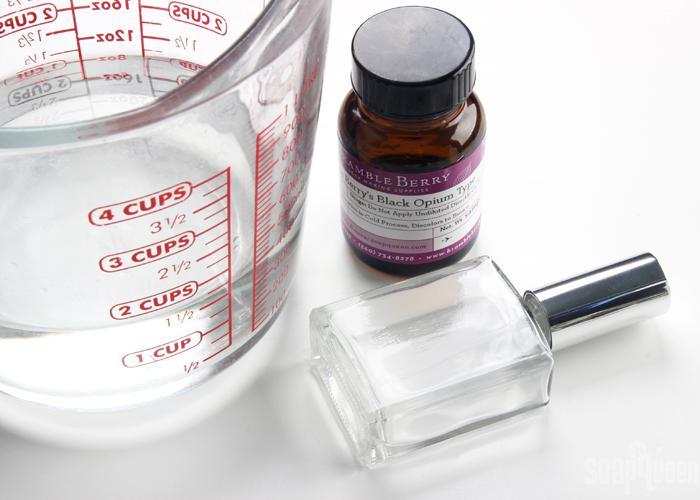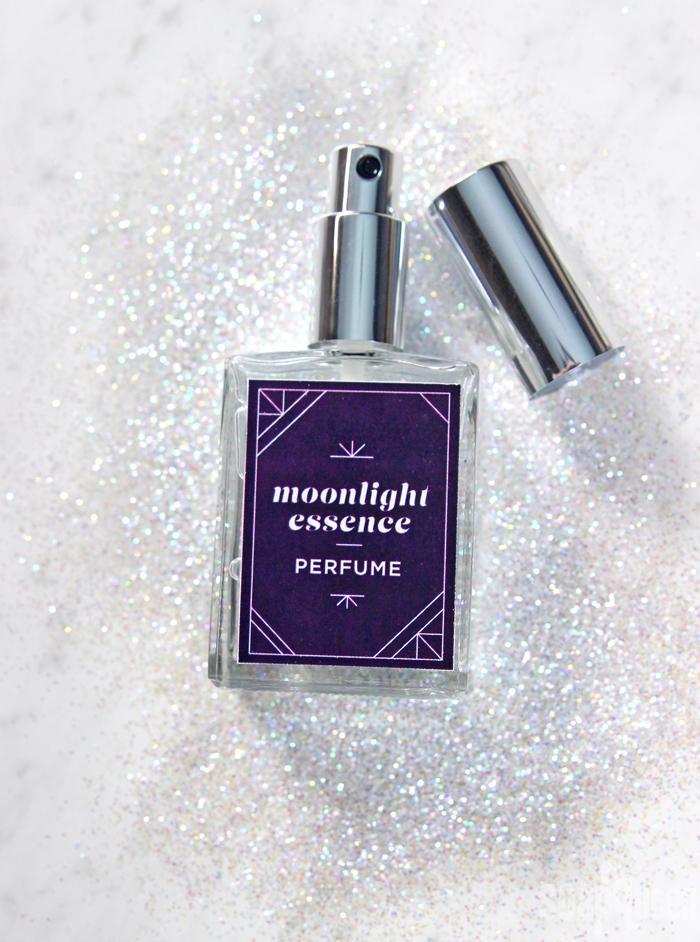The first image is the image on the left, the second image is the image on the right. Given the left and right images, does the statement "A perfume bottle is uncapped." hold true? Answer yes or no. Yes. 